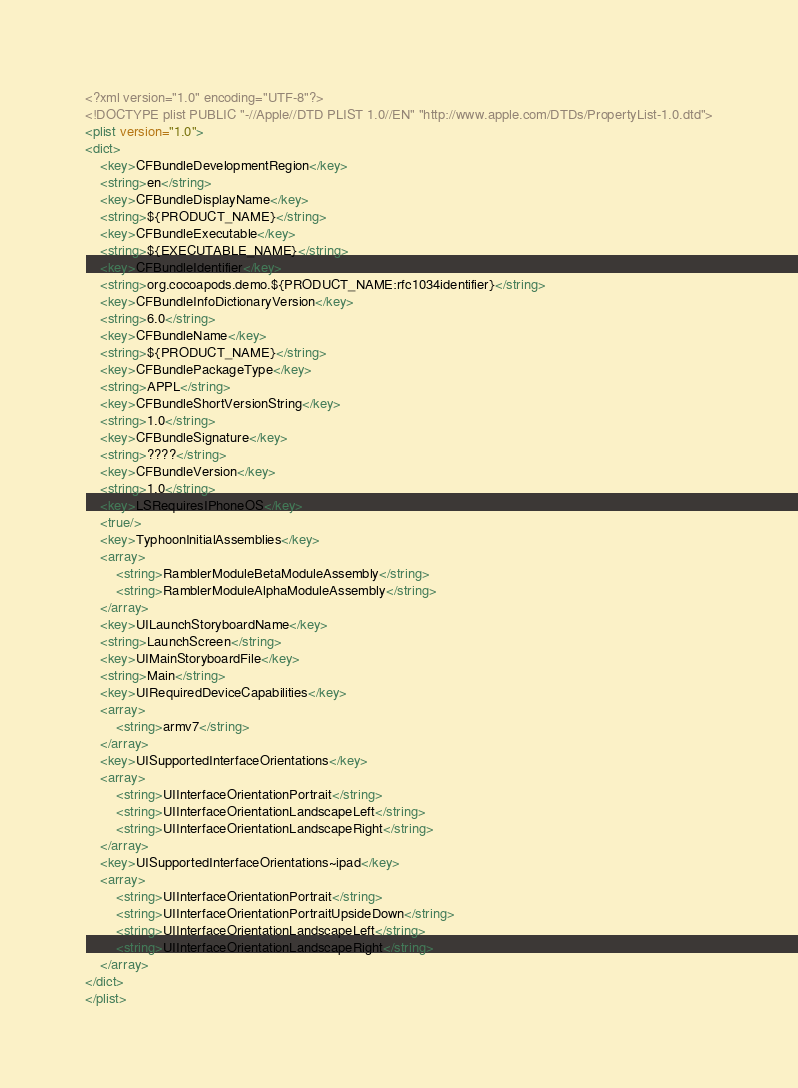<code> <loc_0><loc_0><loc_500><loc_500><_XML_><?xml version="1.0" encoding="UTF-8"?>
<!DOCTYPE plist PUBLIC "-//Apple//DTD PLIST 1.0//EN" "http://www.apple.com/DTDs/PropertyList-1.0.dtd">
<plist version="1.0">
<dict>
	<key>CFBundleDevelopmentRegion</key>
	<string>en</string>
	<key>CFBundleDisplayName</key>
	<string>${PRODUCT_NAME}</string>
	<key>CFBundleExecutable</key>
	<string>${EXECUTABLE_NAME}</string>
	<key>CFBundleIdentifier</key>
	<string>org.cocoapods.demo.${PRODUCT_NAME:rfc1034identifier}</string>
	<key>CFBundleInfoDictionaryVersion</key>
	<string>6.0</string>
	<key>CFBundleName</key>
	<string>${PRODUCT_NAME}</string>
	<key>CFBundlePackageType</key>
	<string>APPL</string>
	<key>CFBundleShortVersionString</key>
	<string>1.0</string>
	<key>CFBundleSignature</key>
	<string>????</string>
	<key>CFBundleVersion</key>
	<string>1.0</string>
	<key>LSRequiresIPhoneOS</key>
	<true/>
	<key>TyphoonInitialAssemblies</key>
	<array>
		<string>RamblerModuleBetaModuleAssembly</string>
		<string>RamblerModuleAlphaModuleAssembly</string>
	</array>
	<key>UILaunchStoryboardName</key>
	<string>LaunchScreen</string>
	<key>UIMainStoryboardFile</key>
	<string>Main</string>
	<key>UIRequiredDeviceCapabilities</key>
	<array>
		<string>armv7</string>
	</array>
	<key>UISupportedInterfaceOrientations</key>
	<array>
		<string>UIInterfaceOrientationPortrait</string>
		<string>UIInterfaceOrientationLandscapeLeft</string>
		<string>UIInterfaceOrientationLandscapeRight</string>
	</array>
	<key>UISupportedInterfaceOrientations~ipad</key>
	<array>
		<string>UIInterfaceOrientationPortrait</string>
		<string>UIInterfaceOrientationPortraitUpsideDown</string>
		<string>UIInterfaceOrientationLandscapeLeft</string>
		<string>UIInterfaceOrientationLandscapeRight</string>
	</array>
</dict>
</plist>
</code> 